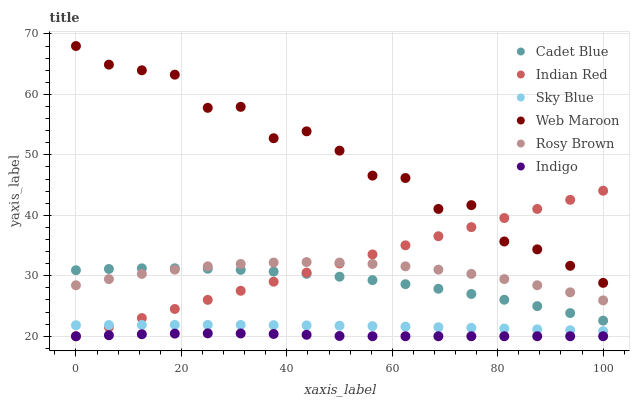Does Indigo have the minimum area under the curve?
Answer yes or no. Yes. Does Web Maroon have the maximum area under the curve?
Answer yes or no. Yes. Does Rosy Brown have the minimum area under the curve?
Answer yes or no. No. Does Rosy Brown have the maximum area under the curve?
Answer yes or no. No. Is Indian Red the smoothest?
Answer yes or no. Yes. Is Web Maroon the roughest?
Answer yes or no. Yes. Is Indigo the smoothest?
Answer yes or no. No. Is Indigo the roughest?
Answer yes or no. No. Does Indigo have the lowest value?
Answer yes or no. Yes. Does Rosy Brown have the lowest value?
Answer yes or no. No. Does Web Maroon have the highest value?
Answer yes or no. Yes. Does Rosy Brown have the highest value?
Answer yes or no. No. Is Sky Blue less than Web Maroon?
Answer yes or no. Yes. Is Web Maroon greater than Sky Blue?
Answer yes or no. Yes. Does Indian Red intersect Web Maroon?
Answer yes or no. Yes. Is Indian Red less than Web Maroon?
Answer yes or no. No. Is Indian Red greater than Web Maroon?
Answer yes or no. No. Does Sky Blue intersect Web Maroon?
Answer yes or no. No. 